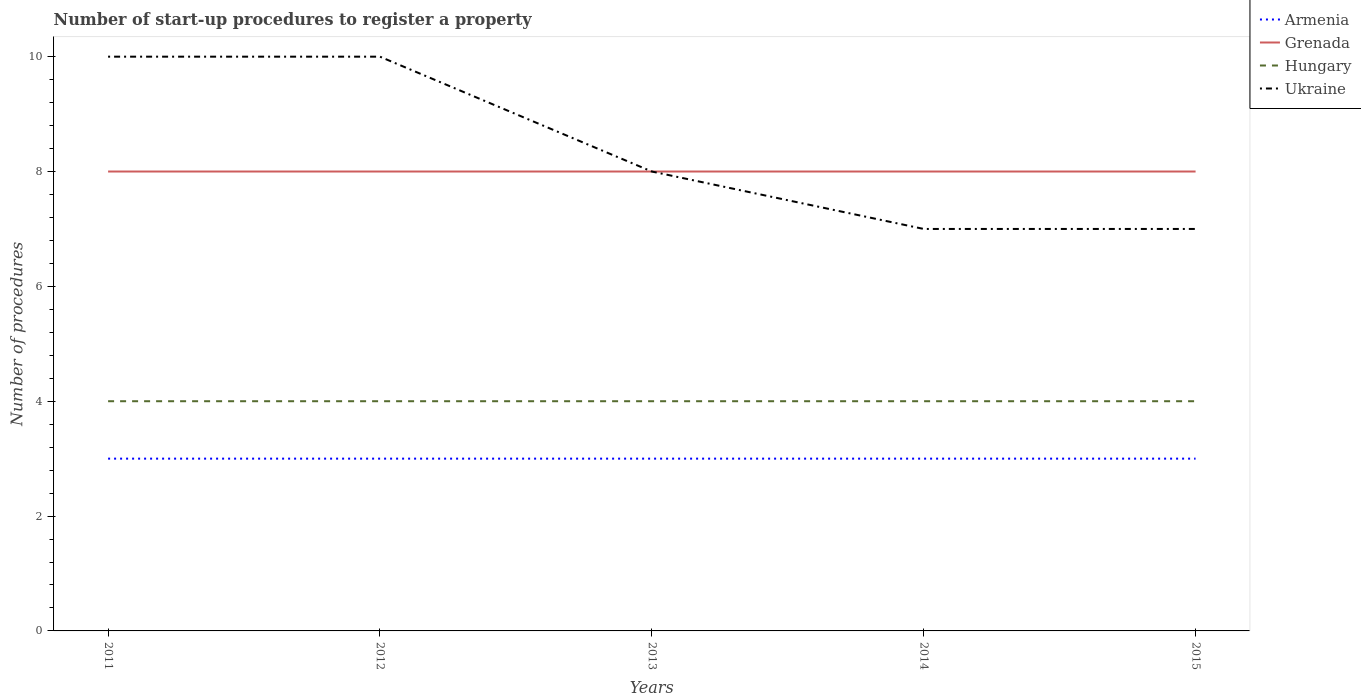Across all years, what is the maximum number of procedures required to register a property in Armenia?
Your answer should be compact. 3. What is the total number of procedures required to register a property in Ukraine in the graph?
Provide a short and direct response. 3. Is the number of procedures required to register a property in Grenada strictly greater than the number of procedures required to register a property in Armenia over the years?
Ensure brevity in your answer.  No. How many lines are there?
Your answer should be compact. 4. How many years are there in the graph?
Your response must be concise. 5. What is the difference between two consecutive major ticks on the Y-axis?
Your response must be concise. 2. Does the graph contain any zero values?
Keep it short and to the point. No. Does the graph contain grids?
Your answer should be very brief. No. Where does the legend appear in the graph?
Ensure brevity in your answer.  Top right. How many legend labels are there?
Your answer should be very brief. 4. How are the legend labels stacked?
Ensure brevity in your answer.  Vertical. What is the title of the graph?
Give a very brief answer. Number of start-up procedures to register a property. Does "Niger" appear as one of the legend labels in the graph?
Provide a short and direct response. No. What is the label or title of the X-axis?
Make the answer very short. Years. What is the label or title of the Y-axis?
Offer a terse response. Number of procedures. What is the Number of procedures of Armenia in 2011?
Your answer should be very brief. 3. What is the Number of procedures of Grenada in 2011?
Make the answer very short. 8. What is the Number of procedures of Armenia in 2012?
Provide a short and direct response. 3. What is the Number of procedures in Grenada in 2012?
Offer a very short reply. 8. What is the Number of procedures in Armenia in 2013?
Your answer should be very brief. 3. What is the Number of procedures of Grenada in 2013?
Your answer should be compact. 8. What is the Number of procedures in Ukraine in 2013?
Your answer should be very brief. 8. What is the Number of procedures of Armenia in 2014?
Keep it short and to the point. 3. What is the Number of procedures of Ukraine in 2014?
Provide a short and direct response. 7. What is the Number of procedures of Hungary in 2015?
Give a very brief answer. 4. Across all years, what is the maximum Number of procedures of Armenia?
Offer a terse response. 3. Across all years, what is the maximum Number of procedures of Grenada?
Provide a short and direct response. 8. Across all years, what is the maximum Number of procedures in Hungary?
Offer a terse response. 4. Across all years, what is the minimum Number of procedures in Armenia?
Make the answer very short. 3. Across all years, what is the minimum Number of procedures of Hungary?
Your answer should be very brief. 4. What is the total Number of procedures in Hungary in the graph?
Give a very brief answer. 20. What is the difference between the Number of procedures of Armenia in 2011 and that in 2012?
Provide a succinct answer. 0. What is the difference between the Number of procedures of Grenada in 2011 and that in 2012?
Provide a succinct answer. 0. What is the difference between the Number of procedures in Hungary in 2011 and that in 2012?
Give a very brief answer. 0. What is the difference between the Number of procedures of Ukraine in 2011 and that in 2012?
Give a very brief answer. 0. What is the difference between the Number of procedures of Armenia in 2011 and that in 2013?
Ensure brevity in your answer.  0. What is the difference between the Number of procedures in Armenia in 2011 and that in 2014?
Ensure brevity in your answer.  0. What is the difference between the Number of procedures in Grenada in 2011 and that in 2014?
Your answer should be very brief. 0. What is the difference between the Number of procedures in Hungary in 2011 and that in 2014?
Keep it short and to the point. 0. What is the difference between the Number of procedures in Ukraine in 2011 and that in 2014?
Your answer should be compact. 3. What is the difference between the Number of procedures of Hungary in 2011 and that in 2015?
Provide a short and direct response. 0. What is the difference between the Number of procedures of Armenia in 2012 and that in 2013?
Offer a very short reply. 0. What is the difference between the Number of procedures in Grenada in 2012 and that in 2013?
Offer a terse response. 0. What is the difference between the Number of procedures of Grenada in 2012 and that in 2014?
Offer a terse response. 0. What is the difference between the Number of procedures of Ukraine in 2012 and that in 2014?
Provide a succinct answer. 3. What is the difference between the Number of procedures of Armenia in 2012 and that in 2015?
Make the answer very short. 0. What is the difference between the Number of procedures of Grenada in 2012 and that in 2015?
Make the answer very short. 0. What is the difference between the Number of procedures of Hungary in 2012 and that in 2015?
Your answer should be compact. 0. What is the difference between the Number of procedures in Grenada in 2013 and that in 2014?
Your response must be concise. 0. What is the difference between the Number of procedures of Ukraine in 2013 and that in 2014?
Keep it short and to the point. 1. What is the difference between the Number of procedures in Grenada in 2013 and that in 2015?
Ensure brevity in your answer.  0. What is the difference between the Number of procedures of Ukraine in 2013 and that in 2015?
Offer a very short reply. 1. What is the difference between the Number of procedures in Armenia in 2011 and the Number of procedures in Grenada in 2012?
Ensure brevity in your answer.  -5. What is the difference between the Number of procedures of Armenia in 2011 and the Number of procedures of Hungary in 2012?
Your answer should be compact. -1. What is the difference between the Number of procedures in Armenia in 2011 and the Number of procedures in Ukraine in 2012?
Your answer should be compact. -7. What is the difference between the Number of procedures of Grenada in 2011 and the Number of procedures of Hungary in 2012?
Your response must be concise. 4. What is the difference between the Number of procedures of Grenada in 2011 and the Number of procedures of Ukraine in 2012?
Provide a succinct answer. -2. What is the difference between the Number of procedures in Armenia in 2011 and the Number of procedures in Ukraine in 2013?
Ensure brevity in your answer.  -5. What is the difference between the Number of procedures of Grenada in 2011 and the Number of procedures of Hungary in 2013?
Ensure brevity in your answer.  4. What is the difference between the Number of procedures of Grenada in 2011 and the Number of procedures of Ukraine in 2013?
Offer a very short reply. 0. What is the difference between the Number of procedures in Hungary in 2011 and the Number of procedures in Ukraine in 2013?
Your response must be concise. -4. What is the difference between the Number of procedures of Armenia in 2011 and the Number of procedures of Hungary in 2014?
Offer a very short reply. -1. What is the difference between the Number of procedures in Armenia in 2011 and the Number of procedures in Ukraine in 2014?
Provide a short and direct response. -4. What is the difference between the Number of procedures in Armenia in 2011 and the Number of procedures in Grenada in 2015?
Offer a very short reply. -5. What is the difference between the Number of procedures in Armenia in 2011 and the Number of procedures in Ukraine in 2015?
Make the answer very short. -4. What is the difference between the Number of procedures in Armenia in 2012 and the Number of procedures in Hungary in 2013?
Provide a short and direct response. -1. What is the difference between the Number of procedures in Armenia in 2012 and the Number of procedures in Ukraine in 2013?
Make the answer very short. -5. What is the difference between the Number of procedures in Grenada in 2012 and the Number of procedures in Hungary in 2013?
Make the answer very short. 4. What is the difference between the Number of procedures of Grenada in 2012 and the Number of procedures of Ukraine in 2013?
Give a very brief answer. 0. What is the difference between the Number of procedures of Grenada in 2012 and the Number of procedures of Ukraine in 2014?
Make the answer very short. 1. What is the difference between the Number of procedures of Hungary in 2012 and the Number of procedures of Ukraine in 2014?
Ensure brevity in your answer.  -3. What is the difference between the Number of procedures in Armenia in 2012 and the Number of procedures in Grenada in 2015?
Give a very brief answer. -5. What is the difference between the Number of procedures in Armenia in 2012 and the Number of procedures in Hungary in 2015?
Ensure brevity in your answer.  -1. What is the difference between the Number of procedures in Grenada in 2012 and the Number of procedures in Ukraine in 2015?
Make the answer very short. 1. What is the difference between the Number of procedures of Hungary in 2012 and the Number of procedures of Ukraine in 2015?
Your answer should be very brief. -3. What is the difference between the Number of procedures in Armenia in 2013 and the Number of procedures in Grenada in 2014?
Provide a short and direct response. -5. What is the difference between the Number of procedures of Grenada in 2013 and the Number of procedures of Hungary in 2014?
Make the answer very short. 4. What is the difference between the Number of procedures in Grenada in 2013 and the Number of procedures in Ukraine in 2014?
Your response must be concise. 1. What is the difference between the Number of procedures of Hungary in 2013 and the Number of procedures of Ukraine in 2014?
Give a very brief answer. -3. What is the difference between the Number of procedures of Grenada in 2013 and the Number of procedures of Hungary in 2015?
Provide a short and direct response. 4. What is the difference between the Number of procedures in Grenada in 2013 and the Number of procedures in Ukraine in 2015?
Your answer should be compact. 1. What is the difference between the Number of procedures of Hungary in 2013 and the Number of procedures of Ukraine in 2015?
Keep it short and to the point. -3. What is the difference between the Number of procedures of Armenia in 2014 and the Number of procedures of Grenada in 2015?
Provide a short and direct response. -5. What is the difference between the Number of procedures of Armenia in 2014 and the Number of procedures of Hungary in 2015?
Your answer should be very brief. -1. What is the difference between the Number of procedures of Armenia in 2014 and the Number of procedures of Ukraine in 2015?
Offer a terse response. -4. What is the difference between the Number of procedures in Grenada in 2014 and the Number of procedures in Hungary in 2015?
Offer a terse response. 4. What is the difference between the Number of procedures in Grenada in 2014 and the Number of procedures in Ukraine in 2015?
Offer a terse response. 1. What is the difference between the Number of procedures of Hungary in 2014 and the Number of procedures of Ukraine in 2015?
Give a very brief answer. -3. What is the average Number of procedures of Grenada per year?
Provide a succinct answer. 8. What is the average Number of procedures in Hungary per year?
Provide a succinct answer. 4. In the year 2011, what is the difference between the Number of procedures of Armenia and Number of procedures of Ukraine?
Your response must be concise. -7. In the year 2012, what is the difference between the Number of procedures in Armenia and Number of procedures in Hungary?
Your answer should be very brief. -1. In the year 2012, what is the difference between the Number of procedures of Armenia and Number of procedures of Ukraine?
Ensure brevity in your answer.  -7. In the year 2012, what is the difference between the Number of procedures of Grenada and Number of procedures of Hungary?
Your response must be concise. 4. In the year 2013, what is the difference between the Number of procedures in Armenia and Number of procedures in Hungary?
Offer a terse response. -1. In the year 2013, what is the difference between the Number of procedures in Armenia and Number of procedures in Ukraine?
Ensure brevity in your answer.  -5. In the year 2013, what is the difference between the Number of procedures of Grenada and Number of procedures of Hungary?
Offer a very short reply. 4. In the year 2013, what is the difference between the Number of procedures in Grenada and Number of procedures in Ukraine?
Provide a succinct answer. 0. In the year 2013, what is the difference between the Number of procedures in Hungary and Number of procedures in Ukraine?
Your response must be concise. -4. In the year 2014, what is the difference between the Number of procedures of Armenia and Number of procedures of Grenada?
Offer a very short reply. -5. In the year 2014, what is the difference between the Number of procedures in Armenia and Number of procedures in Ukraine?
Make the answer very short. -4. In the year 2014, what is the difference between the Number of procedures in Grenada and Number of procedures in Ukraine?
Make the answer very short. 1. In the year 2014, what is the difference between the Number of procedures in Hungary and Number of procedures in Ukraine?
Provide a short and direct response. -3. In the year 2015, what is the difference between the Number of procedures in Armenia and Number of procedures in Grenada?
Give a very brief answer. -5. In the year 2015, what is the difference between the Number of procedures in Armenia and Number of procedures in Hungary?
Give a very brief answer. -1. In the year 2015, what is the difference between the Number of procedures of Armenia and Number of procedures of Ukraine?
Your response must be concise. -4. In the year 2015, what is the difference between the Number of procedures of Grenada and Number of procedures of Hungary?
Your answer should be compact. 4. In the year 2015, what is the difference between the Number of procedures in Grenada and Number of procedures in Ukraine?
Your answer should be very brief. 1. In the year 2015, what is the difference between the Number of procedures of Hungary and Number of procedures of Ukraine?
Give a very brief answer. -3. What is the ratio of the Number of procedures in Armenia in 2011 to that in 2012?
Make the answer very short. 1. What is the ratio of the Number of procedures in Hungary in 2011 to that in 2013?
Make the answer very short. 1. What is the ratio of the Number of procedures of Ukraine in 2011 to that in 2013?
Your answer should be very brief. 1.25. What is the ratio of the Number of procedures of Grenada in 2011 to that in 2014?
Your answer should be compact. 1. What is the ratio of the Number of procedures of Hungary in 2011 to that in 2014?
Give a very brief answer. 1. What is the ratio of the Number of procedures in Ukraine in 2011 to that in 2014?
Ensure brevity in your answer.  1.43. What is the ratio of the Number of procedures of Ukraine in 2011 to that in 2015?
Offer a terse response. 1.43. What is the ratio of the Number of procedures of Armenia in 2012 to that in 2013?
Provide a succinct answer. 1. What is the ratio of the Number of procedures in Hungary in 2012 to that in 2013?
Provide a short and direct response. 1. What is the ratio of the Number of procedures of Ukraine in 2012 to that in 2013?
Ensure brevity in your answer.  1.25. What is the ratio of the Number of procedures of Armenia in 2012 to that in 2014?
Provide a short and direct response. 1. What is the ratio of the Number of procedures in Ukraine in 2012 to that in 2014?
Make the answer very short. 1.43. What is the ratio of the Number of procedures of Armenia in 2012 to that in 2015?
Keep it short and to the point. 1. What is the ratio of the Number of procedures in Hungary in 2012 to that in 2015?
Your response must be concise. 1. What is the ratio of the Number of procedures of Ukraine in 2012 to that in 2015?
Provide a succinct answer. 1.43. What is the ratio of the Number of procedures of Armenia in 2013 to that in 2014?
Keep it short and to the point. 1. What is the ratio of the Number of procedures in Grenada in 2013 to that in 2014?
Keep it short and to the point. 1. What is the ratio of the Number of procedures in Hungary in 2013 to that in 2014?
Offer a very short reply. 1. What is the ratio of the Number of procedures of Ukraine in 2013 to that in 2014?
Provide a succinct answer. 1.14. What is the ratio of the Number of procedures in Grenada in 2013 to that in 2015?
Offer a terse response. 1. What is the ratio of the Number of procedures of Armenia in 2014 to that in 2015?
Keep it short and to the point. 1. What is the difference between the highest and the second highest Number of procedures of Ukraine?
Offer a terse response. 0. What is the difference between the highest and the lowest Number of procedures of Armenia?
Provide a succinct answer. 0. What is the difference between the highest and the lowest Number of procedures of Grenada?
Give a very brief answer. 0. 